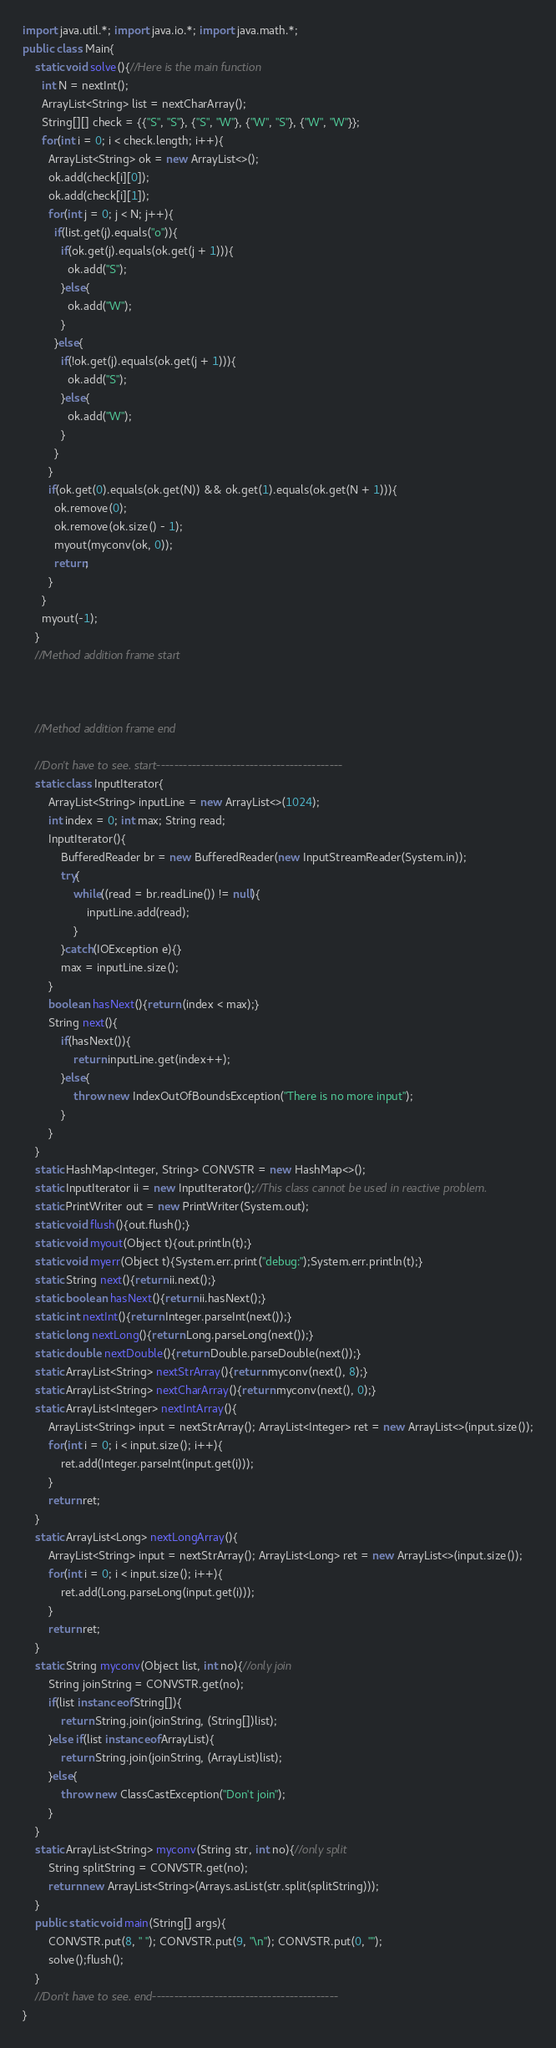<code> <loc_0><loc_0><loc_500><loc_500><_Java_>import java.util.*; import java.io.*; import java.math.*;
public class Main{
	static void solve(){//Here is the main function
      int N = nextInt();
      ArrayList<String> list = nextCharArray();
      String[][] check = {{"S", "S"}, {"S", "W"}, {"W", "S"}, {"W", "W"}};
      for(int i = 0; i < check.length; i++){
        ArrayList<String> ok = new ArrayList<>();
        ok.add(check[i][0]);
        ok.add(check[i][1]);
        for(int j = 0; j < N; j++){
          if(list.get(j).equals("o")){
            if(ok.get(j).equals(ok.get(j + 1))){
              ok.add("S");
            }else{
              ok.add("W");
            }
          }else{
            if(!ok.get(j).equals(ok.get(j + 1))){
              ok.add("S");
            }else{
              ok.add("W");
            }
          }
        }
        if(ok.get(0).equals(ok.get(N)) && ok.get(1).equals(ok.get(N + 1))){
          ok.remove(0);
          ok.remove(ok.size() - 1);
          myout(myconv(ok, 0));
          return;
        }
      }
      myout(-1);
	}
	//Method addition frame start



	//Method addition frame end

	//Don't have to see. start------------------------------------------
	static class InputIterator{
		ArrayList<String> inputLine = new ArrayList<>(1024);
		int index = 0; int max; String read;
		InputIterator(){
			BufferedReader br = new BufferedReader(new InputStreamReader(System.in));
			try{
				while((read = br.readLine()) != null){
					inputLine.add(read);
				}
			}catch(IOException e){}
			max = inputLine.size();
		}
		boolean hasNext(){return (index < max);}
		String next(){
			if(hasNext()){
				return inputLine.get(index++);
			}else{
				throw new IndexOutOfBoundsException("There is no more input");
			}
		}
	}
	static HashMap<Integer, String> CONVSTR = new HashMap<>();
	static InputIterator ii = new InputIterator();//This class cannot be used in reactive problem.
	static PrintWriter out = new PrintWriter(System.out);
	static void flush(){out.flush();}
	static void myout(Object t){out.println(t);}
	static void myerr(Object t){System.err.print("debug:");System.err.println(t);}
	static String next(){return ii.next();}
	static boolean hasNext(){return ii.hasNext();}
	static int nextInt(){return Integer.parseInt(next());}
	static long nextLong(){return Long.parseLong(next());}
	static double nextDouble(){return Double.parseDouble(next());}
	static ArrayList<String> nextStrArray(){return myconv(next(), 8);}
	static ArrayList<String> nextCharArray(){return myconv(next(), 0);}
	static ArrayList<Integer> nextIntArray(){
		ArrayList<String> input = nextStrArray(); ArrayList<Integer> ret = new ArrayList<>(input.size());
		for(int i = 0; i < input.size(); i++){
			ret.add(Integer.parseInt(input.get(i)));
		}
		return ret;
	}
	static ArrayList<Long> nextLongArray(){
		ArrayList<String> input = nextStrArray(); ArrayList<Long> ret = new ArrayList<>(input.size());
		for(int i = 0; i < input.size(); i++){
			ret.add(Long.parseLong(input.get(i)));
		}
		return ret;
	}
	static String myconv(Object list, int no){//only join
		String joinString = CONVSTR.get(no);
		if(list instanceof String[]){
			return String.join(joinString, (String[])list);
		}else if(list instanceof ArrayList){
			return String.join(joinString, (ArrayList)list);
		}else{
			throw new ClassCastException("Don't join");
		}
	}
	static ArrayList<String> myconv(String str, int no){//only split
		String splitString = CONVSTR.get(no);
		return new ArrayList<String>(Arrays.asList(str.split(splitString)));
	}
	public static void main(String[] args){
		CONVSTR.put(8, " "); CONVSTR.put(9, "\n"); CONVSTR.put(0, "");
		solve();flush();
	}
	//Don't have to see. end------------------------------------------
}
</code> 